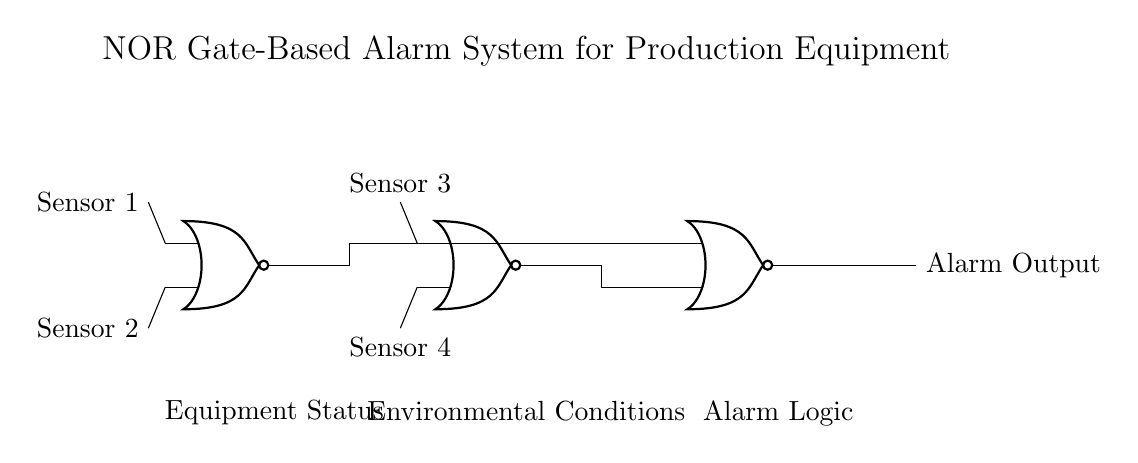What type of logic gates are used in this circuit? The circuit uses NOR gates, which are identified by the recognizable symbol representing NOR logic operations.
Answer: NOR gates How many inputs does the alarm system have? The circuit has four inputs: Sensor 1, Sensor 2, Sensor 3, and Sensor 4, as indicated at the left of the NOR gates.
Answer: Four inputs What does the output of the NOR3 gate represent? The output of the NOR3 gate represents the Alarm Output, which is the final result of the operations performed by the preceding gates based on the sensor inputs.
Answer: Alarm Output What will happen if all sensors are activated? If all sensors are activated, the output of the NOR gates will result in a low signal, meaning that the alarm will not be triggered since NOR gates output a high signal only when all inputs are low.
Answer: No alarm How does the system respond if Sensor 1 and Sensor 2 are both inactive? If both Sensor 1 and Sensor 2 are inactive (low), the output from NOR1 will be high, meaning that the NOR2 will receive a high signal from NOR1, leading to the output of NOR3 also being high, which triggers the alarm.
Answer: Alarm triggers What is the purpose of using multiple NOR gates? Using multiple NOR gates enables complex decision-making based on multiple sensor inputs, allowing the alarm to respond appropriately to various conditions detected by the sensors.
Answer: Complex decision-making What condition specifically activates the alarm output? The alarm output is activated when all sensor inputs are low (inactive). This condition allows for a high output due to the nature of NOR logic.
Answer: All sensors inactive 